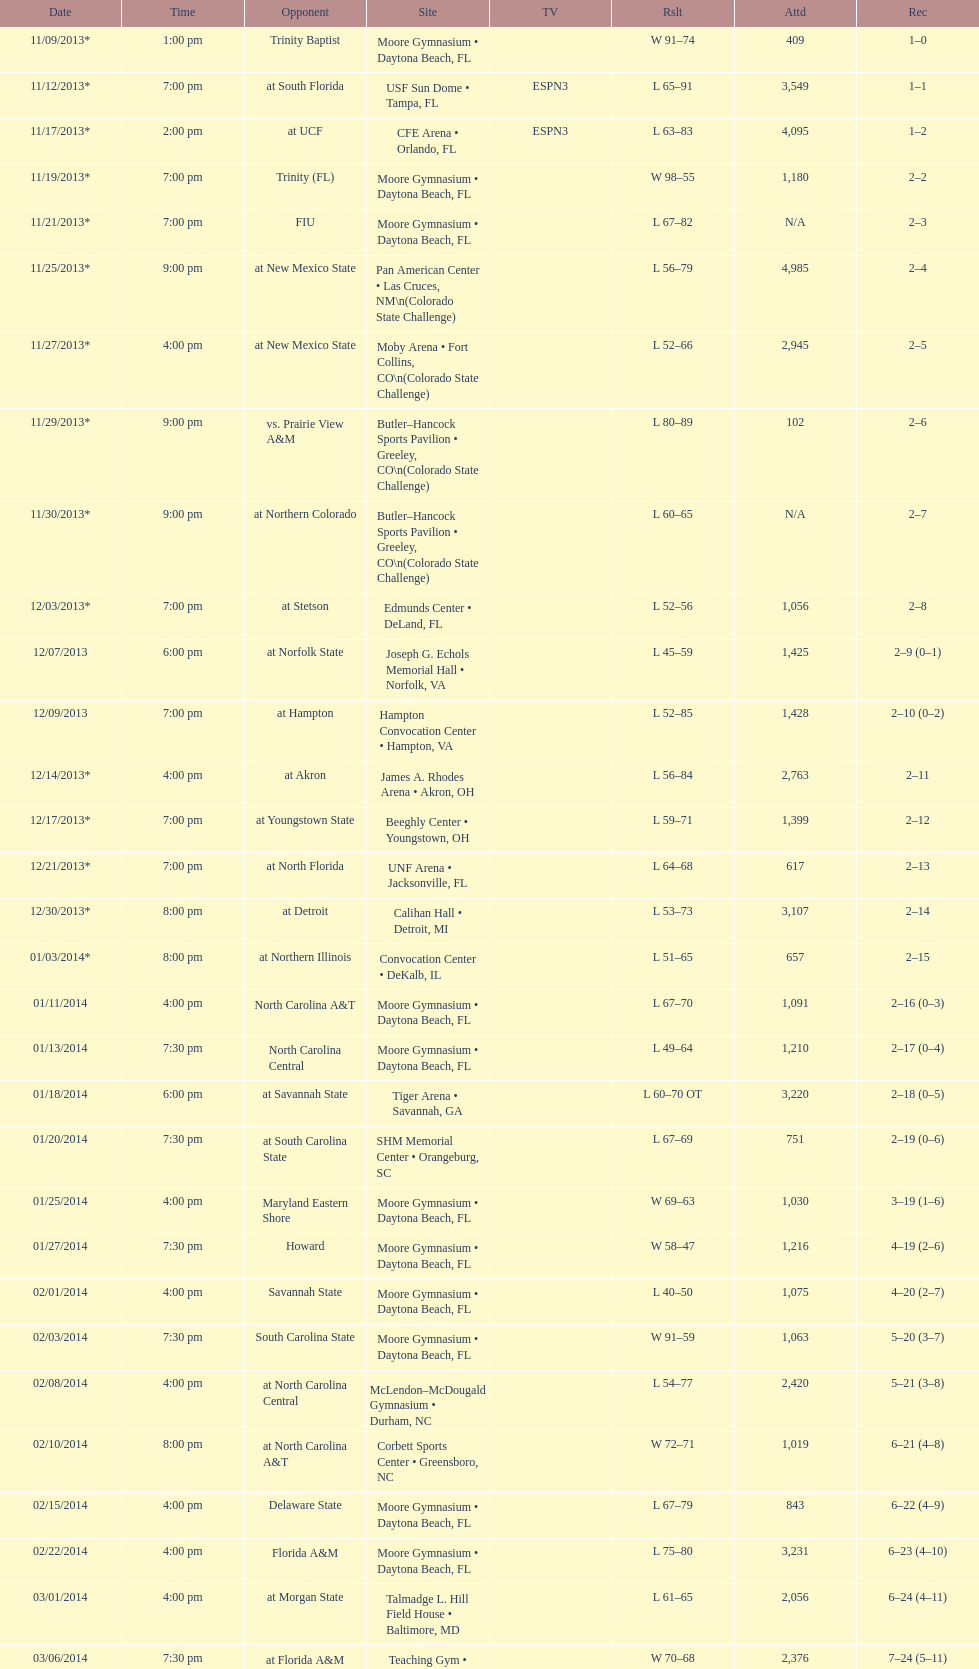How many teams had at most an attendance of 1,000? 6. 